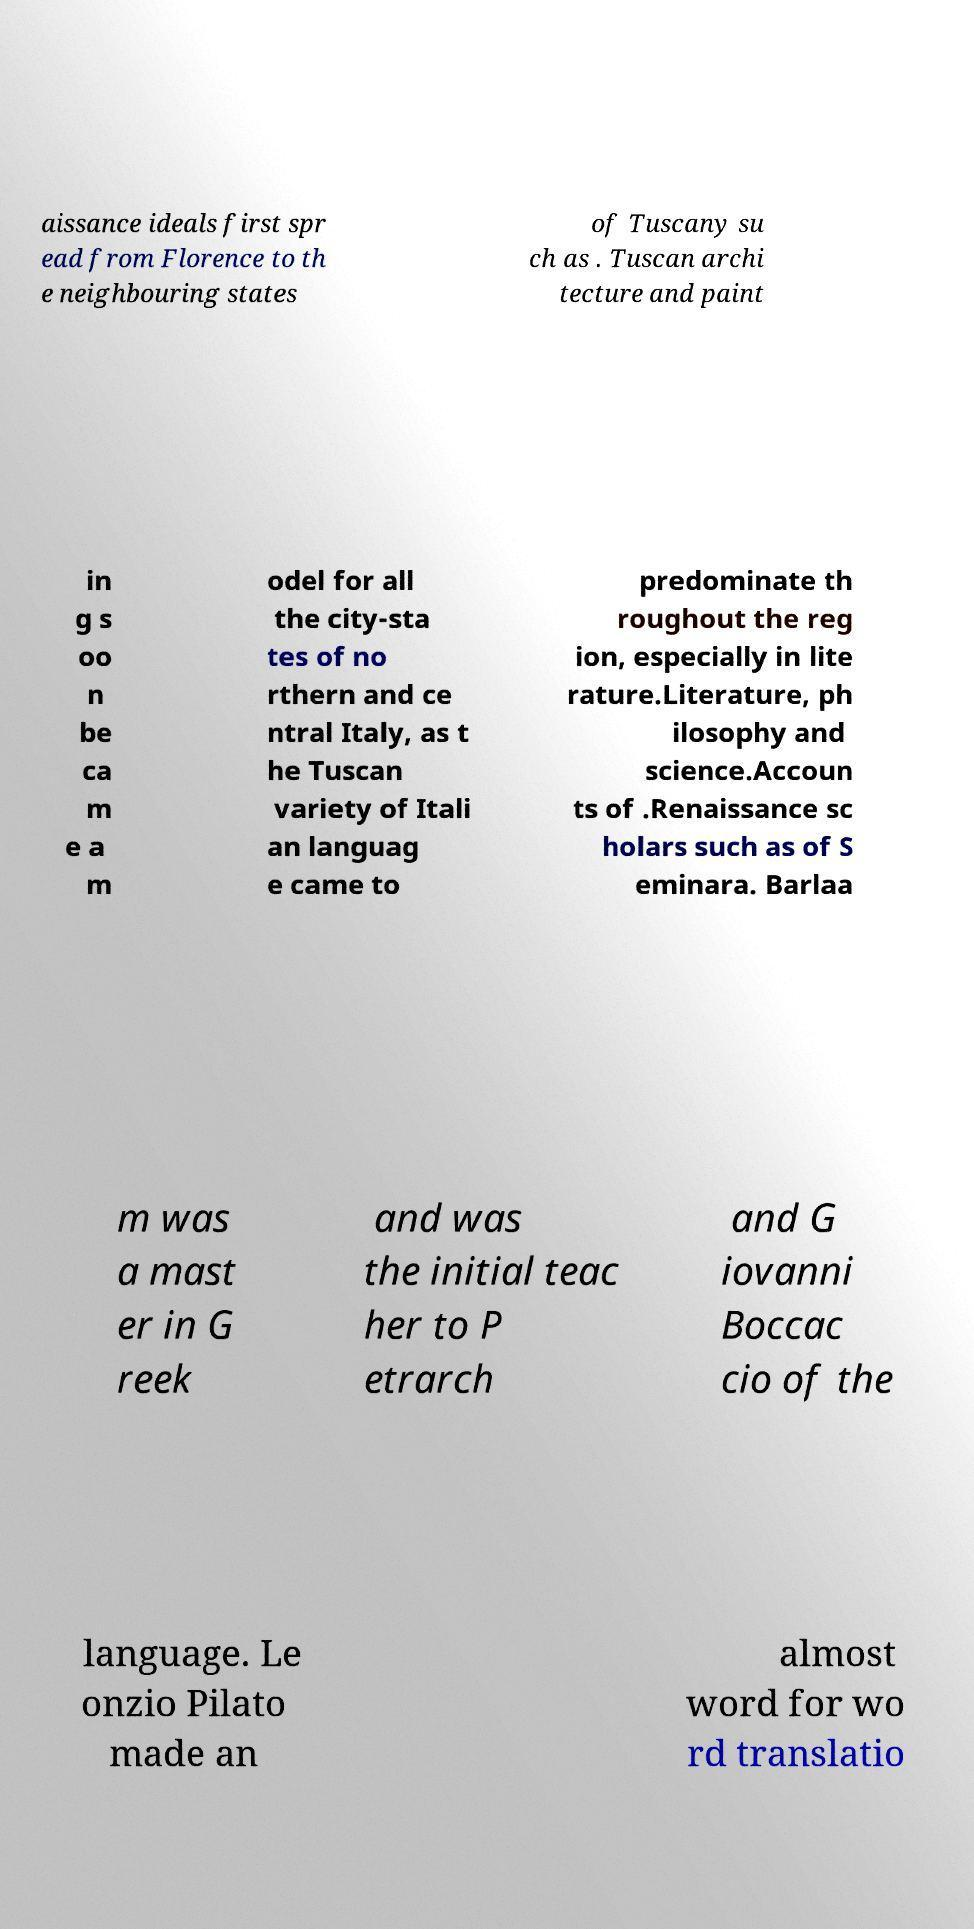Can you accurately transcribe the text from the provided image for me? aissance ideals first spr ead from Florence to th e neighbouring states of Tuscany su ch as . Tuscan archi tecture and paint in g s oo n be ca m e a m odel for all the city-sta tes of no rthern and ce ntral Italy, as t he Tuscan variety of Itali an languag e came to predominate th roughout the reg ion, especially in lite rature.Literature, ph ilosophy and science.Accoun ts of .Renaissance sc holars such as of S eminara. Barlaa m was a mast er in G reek and was the initial teac her to P etrarch and G iovanni Boccac cio of the language. Le onzio Pilato made an almost word for wo rd translatio 